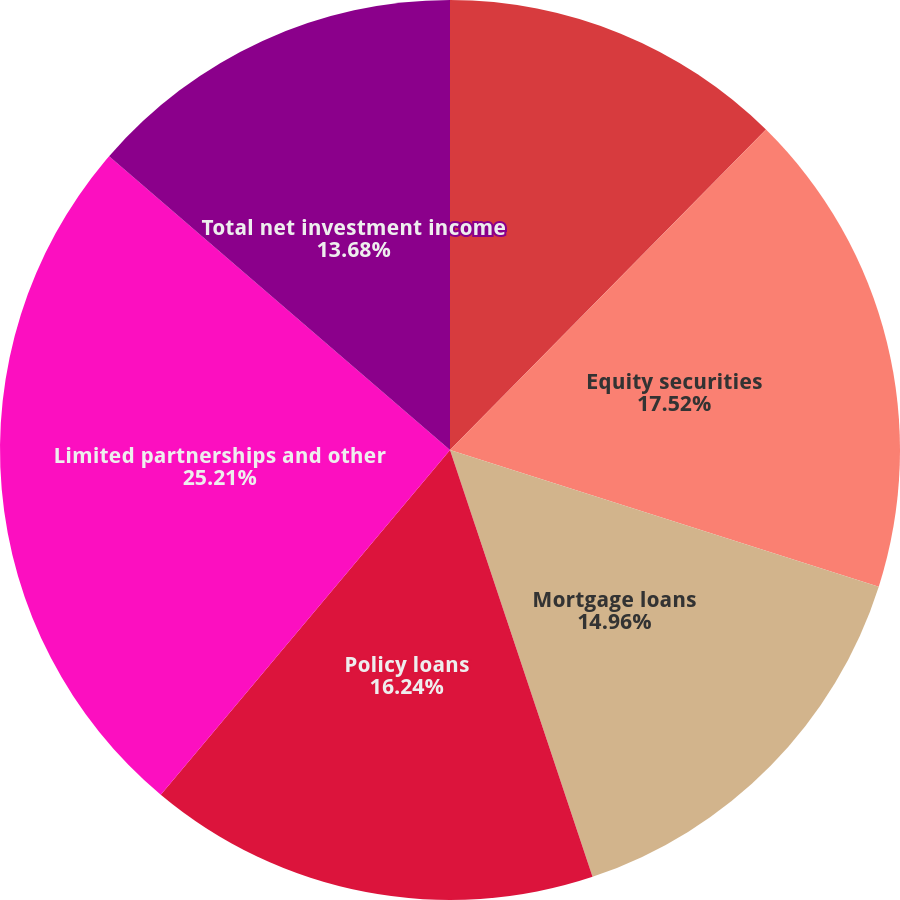<chart> <loc_0><loc_0><loc_500><loc_500><pie_chart><fcel>Fixed maturities 2<fcel>Equity securities<fcel>Mortgage loans<fcel>Policy loans<fcel>Limited partnerships and other<fcel>Total net investment income<nl><fcel>12.39%<fcel>17.52%<fcel>14.96%<fcel>16.24%<fcel>25.21%<fcel>13.68%<nl></chart> 